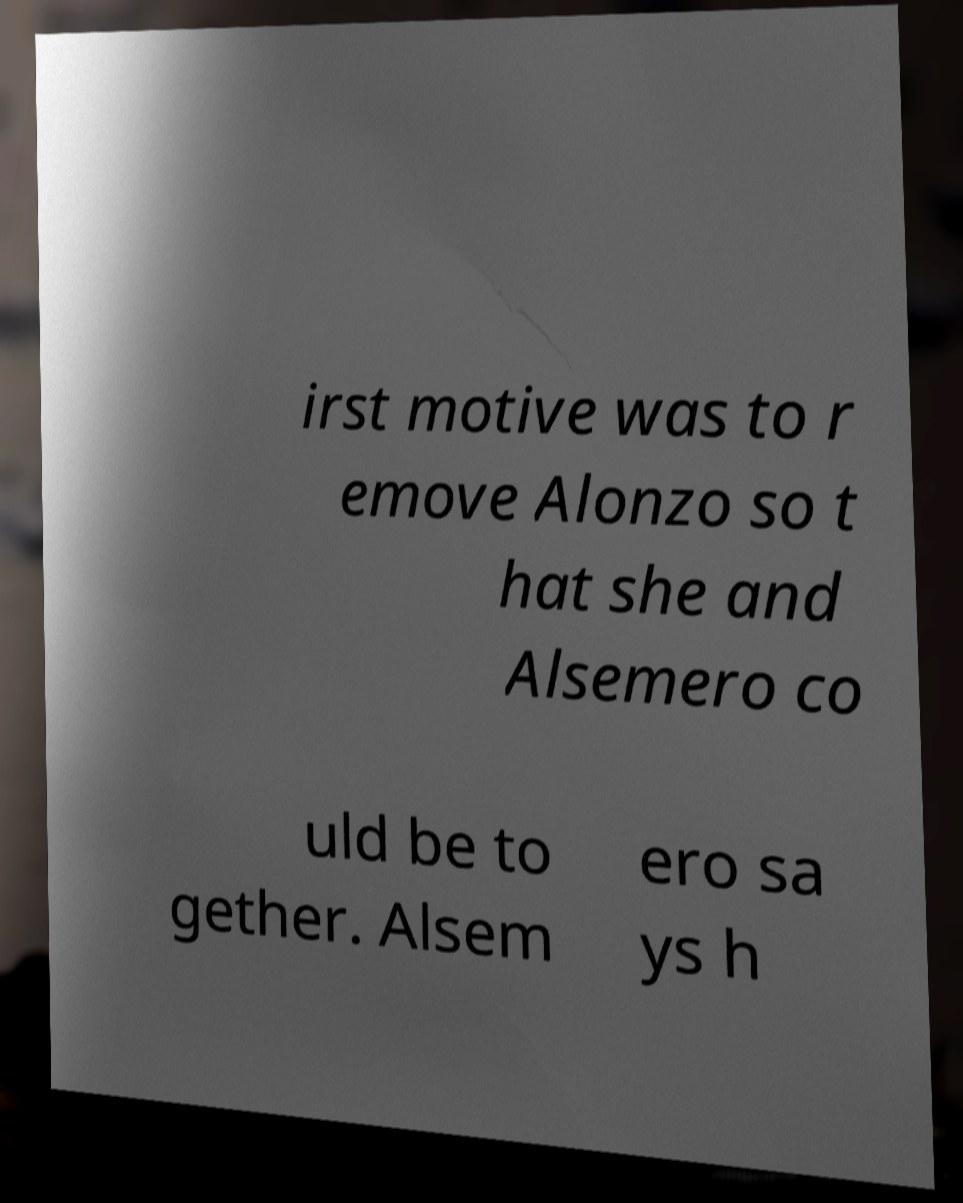Can you accurately transcribe the text from the provided image for me? irst motive was to r emove Alonzo so t hat she and Alsemero co uld be to gether. Alsem ero sa ys h 